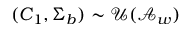Convert formula to latex. <formula><loc_0><loc_0><loc_500><loc_500>( C _ { 1 } , \Sigma _ { b } ) \sim \mathcal { U } ( \mathcal { A } _ { w } )</formula> 